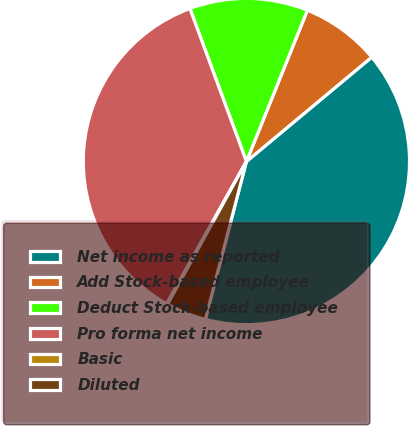<chart> <loc_0><loc_0><loc_500><loc_500><pie_chart><fcel>Net income as reported<fcel>Add Stock-based employee<fcel>Deduct Stock-based employee<fcel>Pro forma net income<fcel>Basic<fcel>Diluted<nl><fcel>40.11%<fcel>7.85%<fcel>11.73%<fcel>36.24%<fcel>0.1%<fcel>3.98%<nl></chart> 